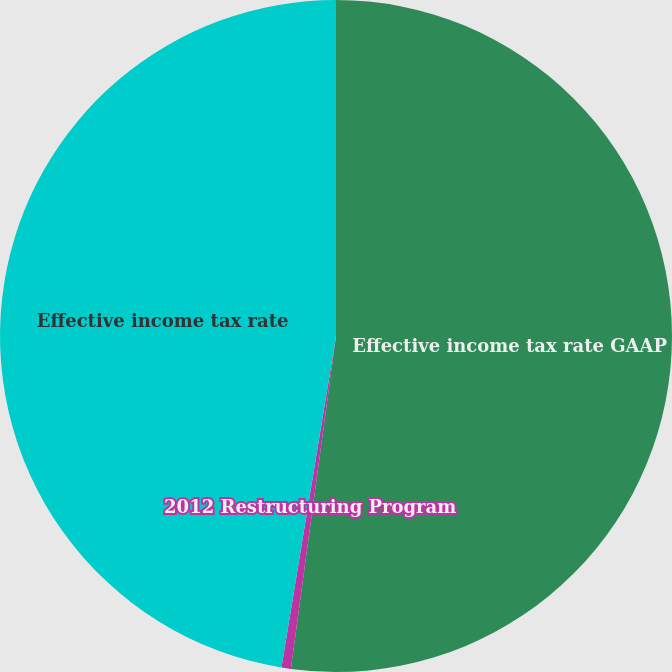Convert chart to OTSL. <chart><loc_0><loc_0><loc_500><loc_500><pie_chart><fcel>Effective income tax rate GAAP<fcel>2012 Restructuring Program<fcel>Effective income tax rate<nl><fcel>52.15%<fcel>0.45%<fcel>47.41%<nl></chart> 